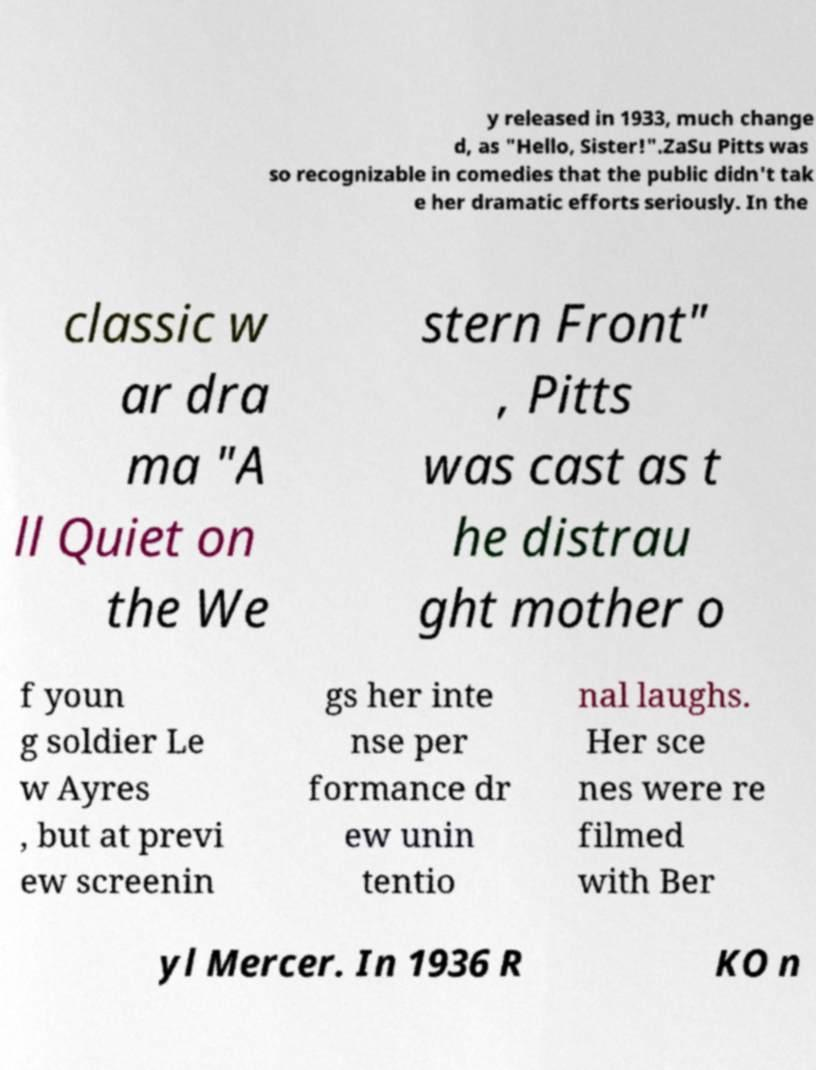There's text embedded in this image that I need extracted. Can you transcribe it verbatim? y released in 1933, much change d, as "Hello, Sister!".ZaSu Pitts was so recognizable in comedies that the public didn't tak e her dramatic efforts seriously. In the classic w ar dra ma "A ll Quiet on the We stern Front" , Pitts was cast as t he distrau ght mother o f youn g soldier Le w Ayres , but at previ ew screenin gs her inte nse per formance dr ew unin tentio nal laughs. Her sce nes were re filmed with Ber yl Mercer. In 1936 R KO n 